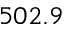Convert formula to latex. <formula><loc_0><loc_0><loc_500><loc_500>5 0 2 . 9</formula> 